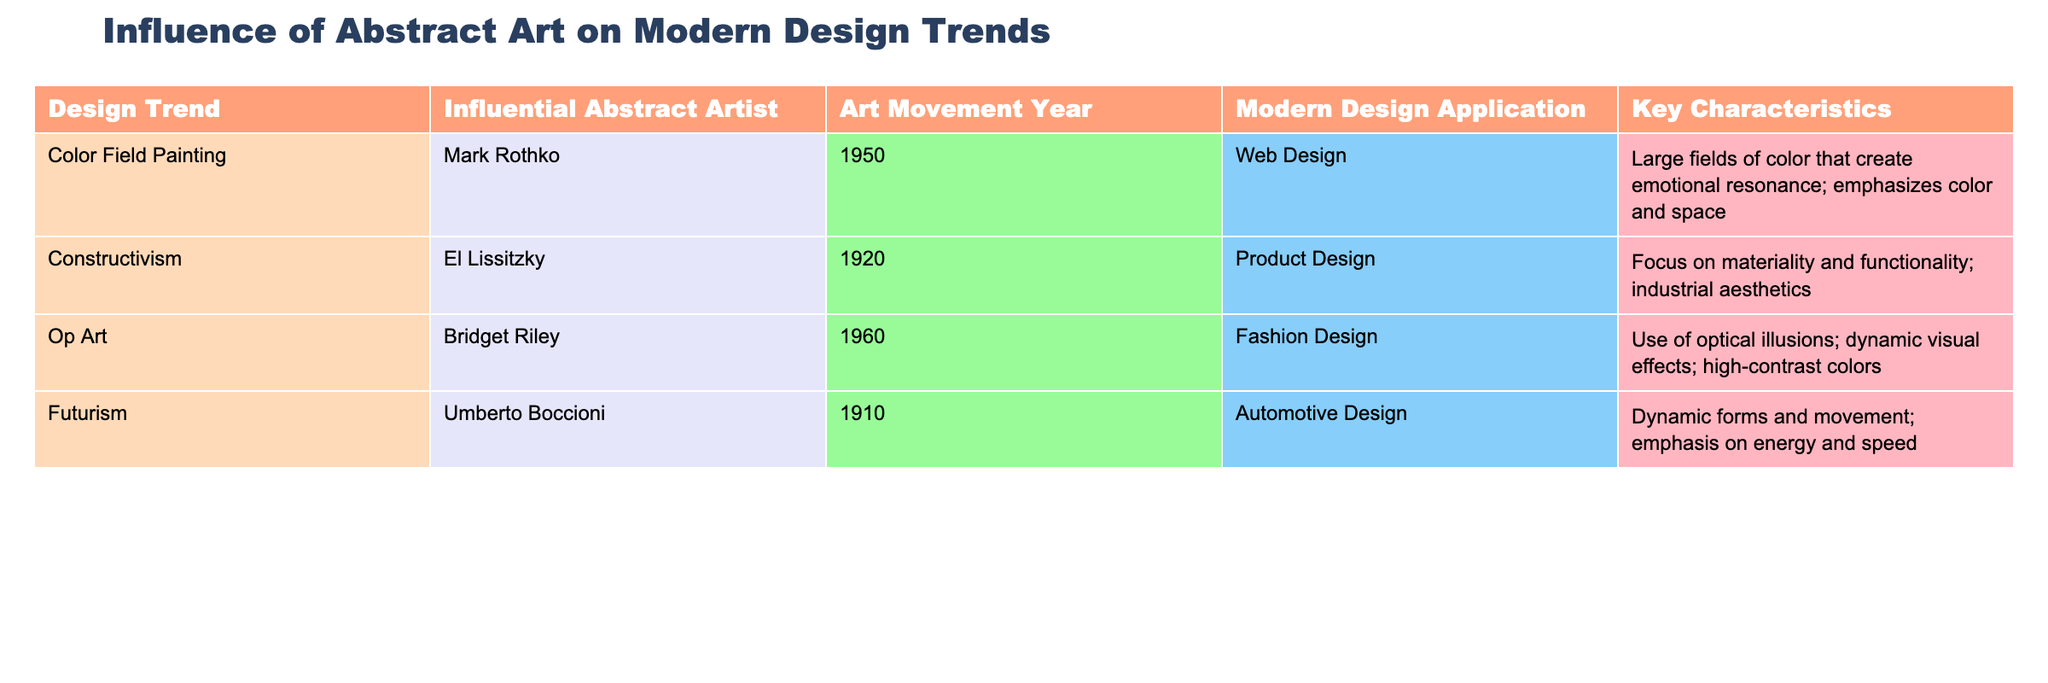What design trend is associated with Mark Rothko? According to the table, the design trend linked with Mark Rothko is "Color Field Painting." This can be found directly in the first row under the "Influential Abstract Artist" column.
Answer: Color Field Painting Which modern design application corresponds to the Op Art movement? The table indicates that the modern design application for the Op Art movement is "Fashion Design," as shown in the third row under the "Modern Design Application" column.
Answer: Fashion Design How many design trends are listed in the table? The table contains a total of four design trends, each listed as a unique entry in the "Design Trend" column.
Answer: 4 Is Futurism related to product design? The table shows that Futurism is connected with "Automotive Design," not product design. Therefore, this statement is false.
Answer: No Which influential abstract artist's work is noted for its focus on materiality and functionality? The table specifies that El Lissitzky, an influential abstract artist from the Constructivism movement, emphasizes materiality and functionality. This is reflected in the second row of the table.
Answer: El Lissitzky What is the key characteristic of Color Field Painting in modern design? The key characteristic of Color Field Painting, as per the table, is "Large fields of color that create emotional resonance; emphasizes color and space," which can be found in the relevant row under the "Key Characteristics" column.
Answer: Large fields of color Are there any design trends influenced by artists from the 1910s? Yes, the table mentions Futurism influenced by Umberto Boccioni, who is from the 1910s. Hence the answer is yes.
Answer: Yes What do the key characteristics of Op Art emphasize? The key characteristics of Op Art highlight "Use of optical illusions; dynamic visual effects; high-contrast colors," detailed in the corresponding row under the "Key Characteristics" column.
Answer: Optical illusions and dynamic effects Which art movement year has the latest associated design application listed? The latest art movement year associated with a design application in the table is 1960, corresponding to Op Art, which is linked to "Fashion Design." This can be confirmed by checking all the years in the "Art Movement Year" column.
Answer: 1960 